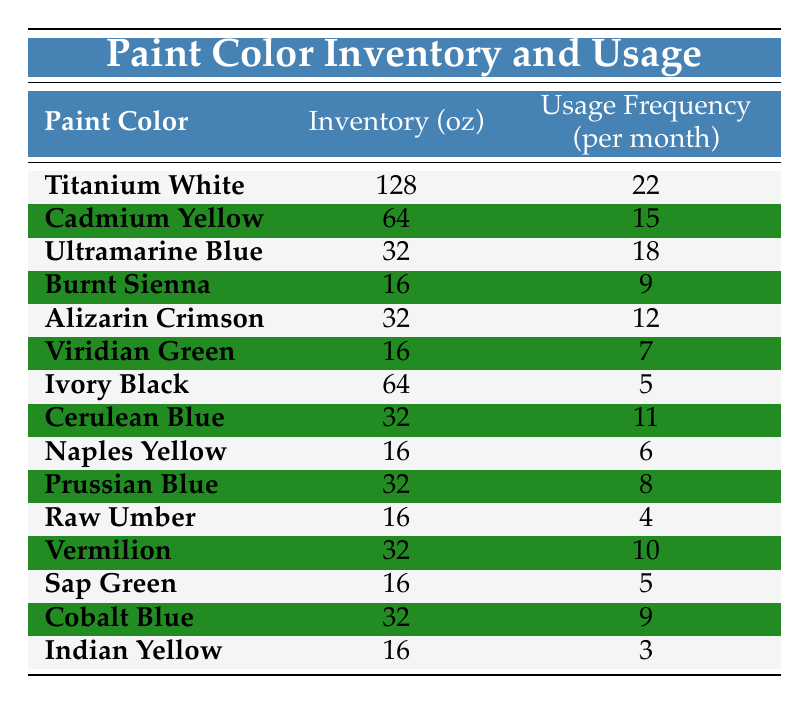What is the inventory of Titanium White? The table lists the inventory for Titanium White in the "Inventory (oz)" column. According to the table, Titanium White has an inventory of 128 oz.
Answer: 128 oz Which paint color has the highest usage frequency? To find the highest usage frequency, we can compare the values in the "Usage Frequency (per month)" column. Titanium White has a frequency of 22, which is greater than all other colors, so it is the highest.
Answer: Titanium White What is the total inventory of paints that have a usage frequency greater than 10? First, we identify the paints with a usage frequency greater than 10: Titanium White (22), Cadmium Yellow (15), Ultramarine Blue (18), Alizarin Crimson (12), and Vermilion (10). Their inventories are 128, 64, 32, 32, and 32 oz respectively. Adding these gives us a total of 128 + 64 + 32 + 32 + 32 = 288 oz.
Answer: 288 oz Is the usage frequency of Cerulean Blue greater than that of Burnt Sienna? The usage frequency of Cerulean Blue is 11, while Burnt Sienna's frequency is 9. Since 11 is greater than 9, the answer is yes.
Answer: Yes What is the average inventory of paints with a usage frequency of less than 5? First, we identify the paints with a usage frequency of less than 5, which are Ivory Black (5), Raw Umber (4), Sap Green (5), and Indian Yellow (3). However, only Indian Yellow has a frequency less than 5 with an inventory of 16 oz. Since we have only one paint in this category, the average inventory is simply 16 oz.
Answer: 16 oz What color has an inventory of 16 oz and a usage frequency of less than 5? The paints with an inventory of 16 oz are Burnt Sienna, Viridian Green, Naples Yellow, Raw Umber, Sap Green, and Indian Yellow. Among these, only Indian Yellow has a usage frequency of 3, which is less than 5.
Answer: Indian Yellow What is the sum of the usage frequency of all paint colors with an inventory of 16 oz? The colors with 16 oz inventory are Burnt Sienna (9), Viridian Green (7), Naples Yellow (6), Raw Umber (4), Sap Green (5), and Indian Yellow (3). We can add them: 9 + 7 + 6 + 4 + 5 + 3 = 34.
Answer: 34 Is the inventory of Cadmium Yellow equal to that of Ivory Black? Looking at the "Inventory (oz)" column, Cadmium Yellow has an inventory of 64 oz, while Ivory Black also has 64 oz. Since both are equal, the answer is yes.
Answer: Yes 